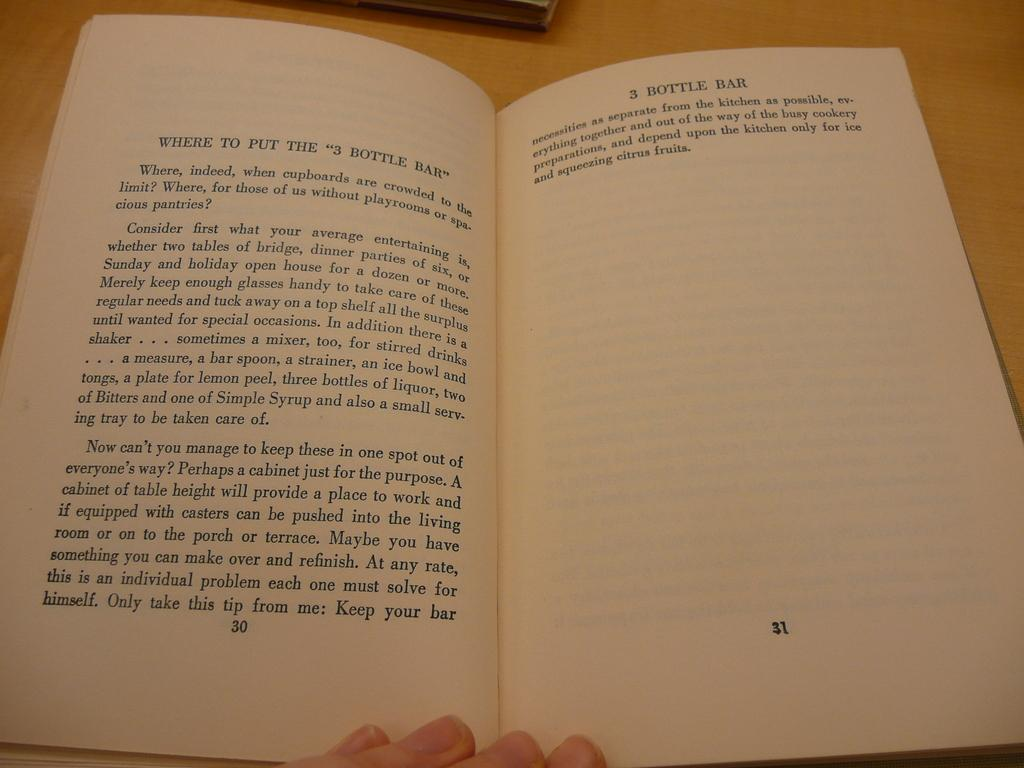<image>
Relay a brief, clear account of the picture shown. A book is open to a page that starts with "WHERE TO PUT" 